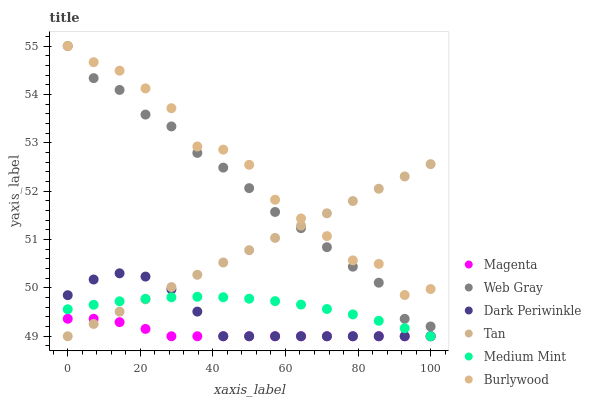Does Magenta have the minimum area under the curve?
Answer yes or no. Yes. Does Burlywood have the maximum area under the curve?
Answer yes or no. Yes. Does Web Gray have the minimum area under the curve?
Answer yes or no. No. Does Web Gray have the maximum area under the curve?
Answer yes or no. No. Is Tan the smoothest?
Answer yes or no. Yes. Is Burlywood the roughest?
Answer yes or no. Yes. Is Web Gray the smoothest?
Answer yes or no. No. Is Web Gray the roughest?
Answer yes or no. No. Does Medium Mint have the lowest value?
Answer yes or no. Yes. Does Web Gray have the lowest value?
Answer yes or no. No. Does Burlywood have the highest value?
Answer yes or no. Yes. Does Dark Periwinkle have the highest value?
Answer yes or no. No. Is Dark Periwinkle less than Web Gray?
Answer yes or no. Yes. Is Web Gray greater than Medium Mint?
Answer yes or no. Yes. Does Web Gray intersect Burlywood?
Answer yes or no. Yes. Is Web Gray less than Burlywood?
Answer yes or no. No. Is Web Gray greater than Burlywood?
Answer yes or no. No. Does Dark Periwinkle intersect Web Gray?
Answer yes or no. No. 